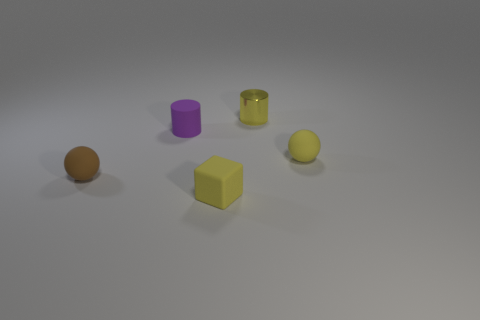Is there any other thing that is the same material as the purple thing?
Your answer should be compact. Yes. There is a purple object that is the same shape as the tiny yellow shiny thing; what is its size?
Make the answer very short. Small. Are there more tiny brown spheres that are in front of the small purple rubber thing than tiny cyan rubber spheres?
Your answer should be very brief. Yes. Are the yellow thing that is in front of the small yellow ball and the small yellow ball made of the same material?
Offer a terse response. Yes. What is the size of the yellow rubber object that is behind the sphere that is to the left of the cylinder that is behind the small purple cylinder?
Your response must be concise. Small. The brown sphere that is the same material as the tiny purple cylinder is what size?
Your answer should be compact. Small. The tiny rubber object that is on the right side of the purple cylinder and behind the small yellow rubber block is what color?
Provide a short and direct response. Yellow. Is the shape of the small matte object that is to the right of the tiny block the same as the rubber object left of the tiny purple matte thing?
Provide a short and direct response. Yes. There is a cylinder that is in front of the yellow metallic cylinder; what material is it?
Your response must be concise. Rubber. There is a rubber sphere that is the same color as the metal cylinder; what size is it?
Keep it short and to the point. Small. 